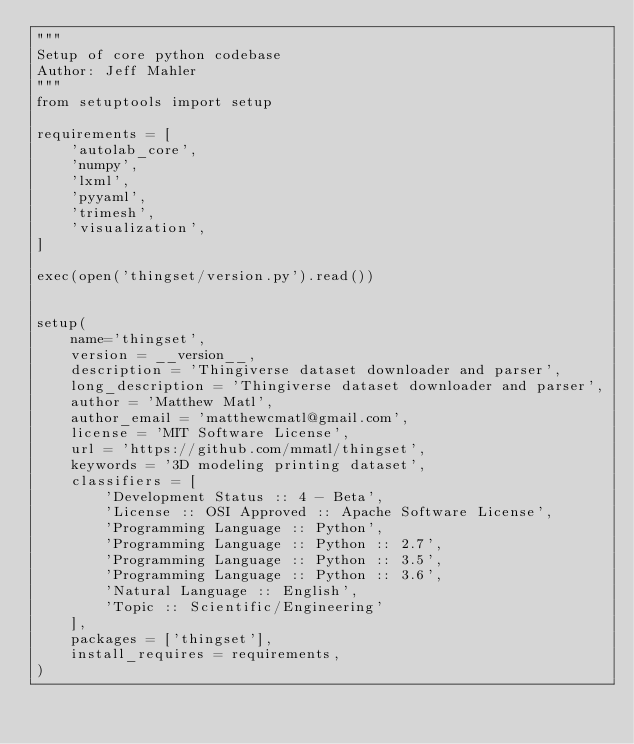<code> <loc_0><loc_0><loc_500><loc_500><_Python_>"""
Setup of core python codebase
Author: Jeff Mahler
"""
from setuptools import setup

requirements = [
    'autolab_core',
    'numpy',
    'lxml',
    'pyyaml',
    'trimesh',
    'visualization',
]

exec(open('thingset/version.py').read())


setup(
    name='thingset',
    version = __version__,
    description = 'Thingiverse dataset downloader and parser',
    long_description = 'Thingiverse dataset downloader and parser',
    author = 'Matthew Matl',
    author_email = 'matthewcmatl@gmail.com',
    license = 'MIT Software License',
    url = 'https://github.com/mmatl/thingset',
    keywords = '3D modeling printing dataset',
    classifiers = [
        'Development Status :: 4 - Beta',
        'License :: OSI Approved :: Apache Software License',
        'Programming Language :: Python',
        'Programming Language :: Python :: 2.7',
        'Programming Language :: Python :: 3.5',
        'Programming Language :: Python :: 3.6',
        'Natural Language :: English',
        'Topic :: Scientific/Engineering'
    ],
    packages = ['thingset'],
    install_requires = requirements,
)

</code> 